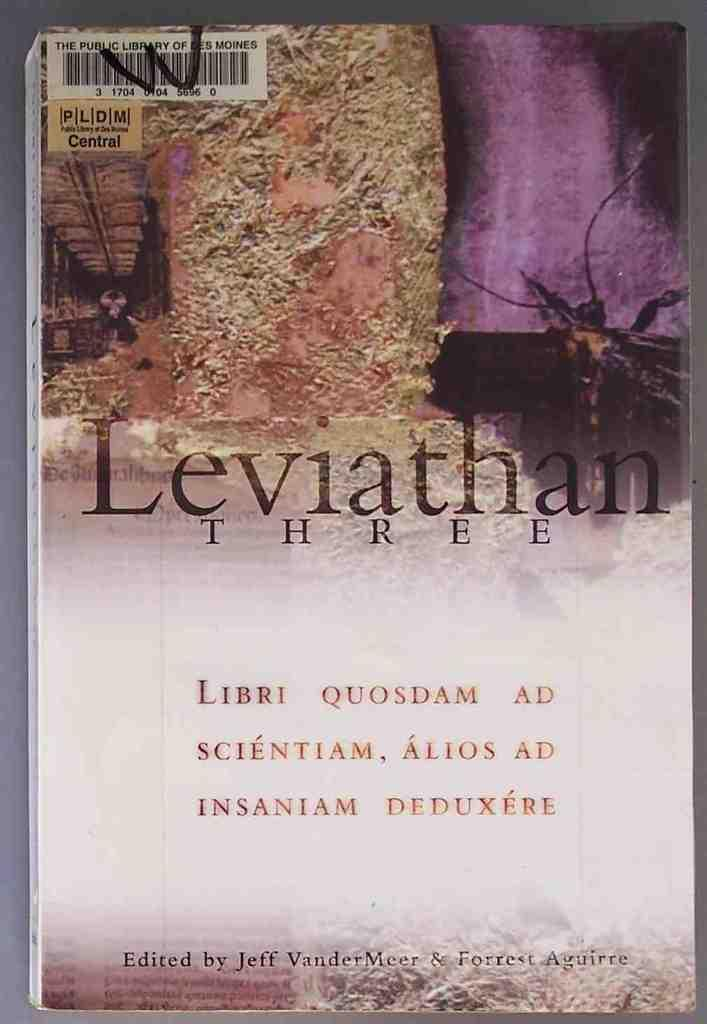<image>
Write a terse but informative summary of the picture. the word Leviathan that is on a book 